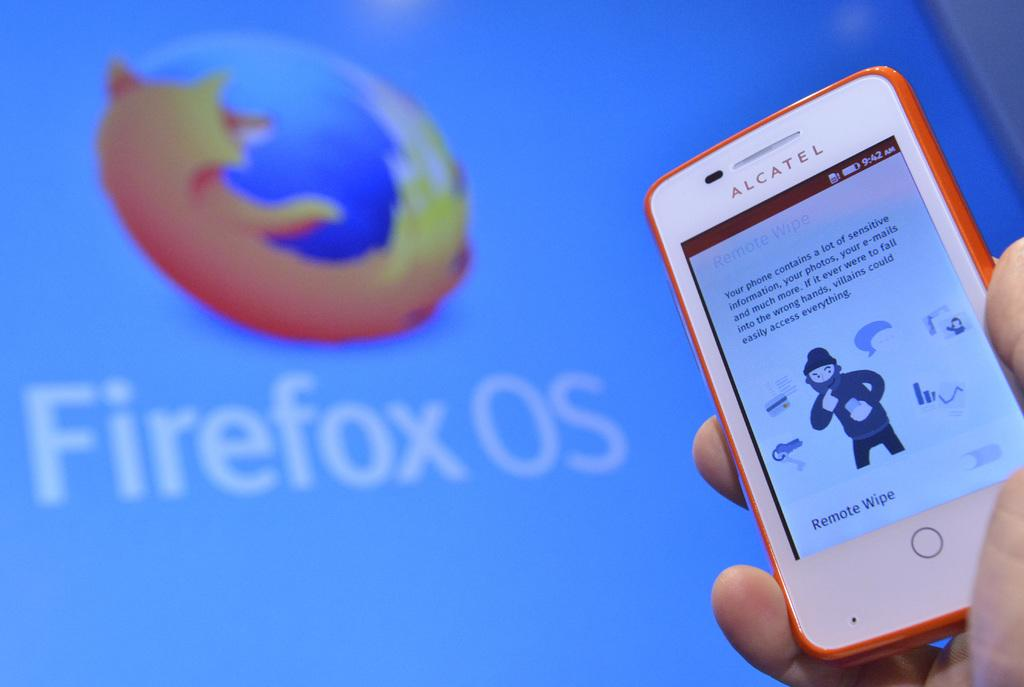Provide a one-sentence caption for the provided image. A hand is holding a small Alcatel cellphone in front of a large screen displaying Firefox OS. 